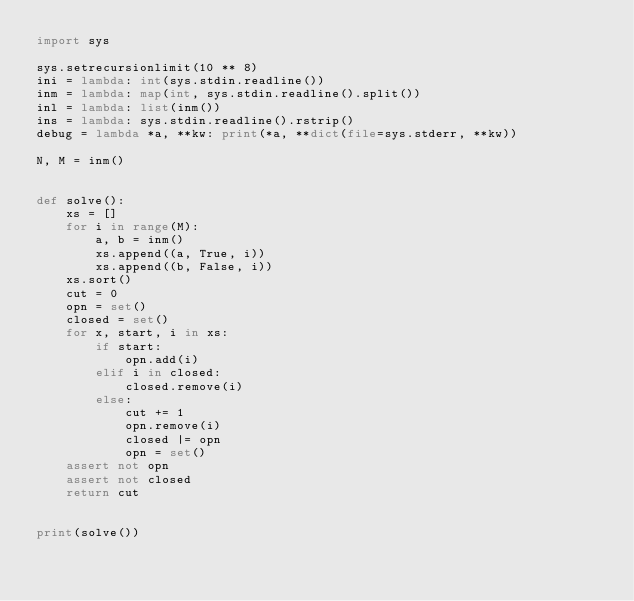Convert code to text. <code><loc_0><loc_0><loc_500><loc_500><_Python_>import sys

sys.setrecursionlimit(10 ** 8)
ini = lambda: int(sys.stdin.readline())
inm = lambda: map(int, sys.stdin.readline().split())
inl = lambda: list(inm())
ins = lambda: sys.stdin.readline().rstrip()
debug = lambda *a, **kw: print(*a, **dict(file=sys.stderr, **kw))

N, M = inm()


def solve():
    xs = []
    for i in range(M):
        a, b = inm()
        xs.append((a, True, i))
        xs.append((b, False, i))
    xs.sort()
    cut = 0
    opn = set()
    closed = set()
    for x, start, i in xs:
        if start:
            opn.add(i)
        elif i in closed:
            closed.remove(i)
        else:
            cut += 1
            opn.remove(i)
            closed |= opn
            opn = set()
    assert not opn
    assert not closed
    return cut


print(solve())
</code> 